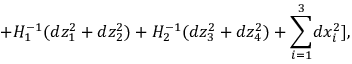<formula> <loc_0><loc_0><loc_500><loc_500>+ H _ { 1 } ^ { - 1 } ( d z _ { 1 } ^ { 2 } + d z _ { 2 } ^ { 2 } ) + H _ { 2 } ^ { - 1 } ( d z _ { 3 } ^ { 2 } + d z _ { 4 } ^ { 2 } ) + { \sum _ { i = 1 } ^ { 3 } } d x _ { i } ^ { 2 } ] ,</formula> 